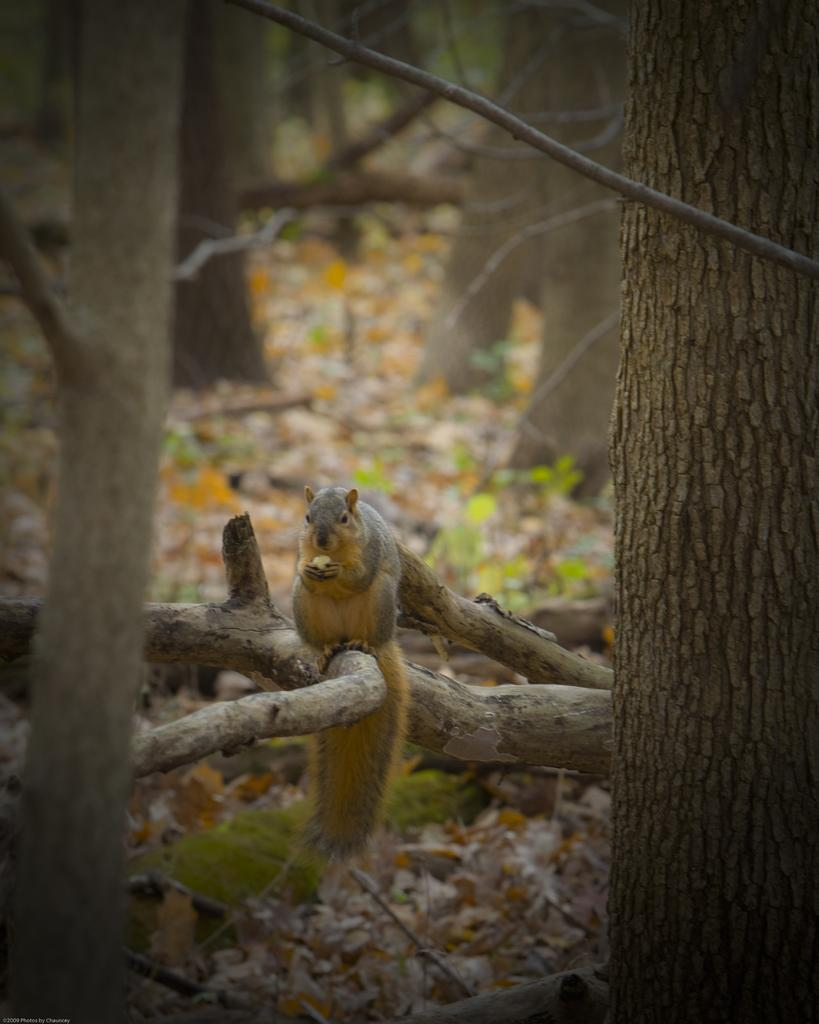What type of vegetation can be seen in the image? There are trees in the image. Are there any animals present in the image? Yes, there is a squirrel in the image. Where is the squirrel located in relation to the trees? The squirrel is sitting on a branch of one of the trees. What type of selection is the writer making in the image? There is no writer or selection present in the image; it features trees and a squirrel. 